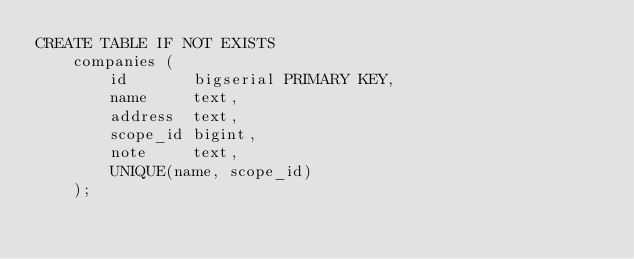<code> <loc_0><loc_0><loc_500><loc_500><_SQL_>CREATE TABLE IF NOT EXISTS 
    companies (
        id       bigserial PRIMARY KEY,
        name     text,
        address  text,
        scope_id bigint,
        note     text,
        UNIQUE(name, scope_id)
    );</code> 